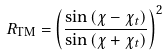Convert formula to latex. <formula><loc_0><loc_0><loc_500><loc_500>R _ { \text {TM} } = \left ( \frac { \sin { ( \chi - \chi _ { t } ) } } { \sin { ( \chi + \chi _ { t } ) } } \right ) ^ { 2 }</formula> 